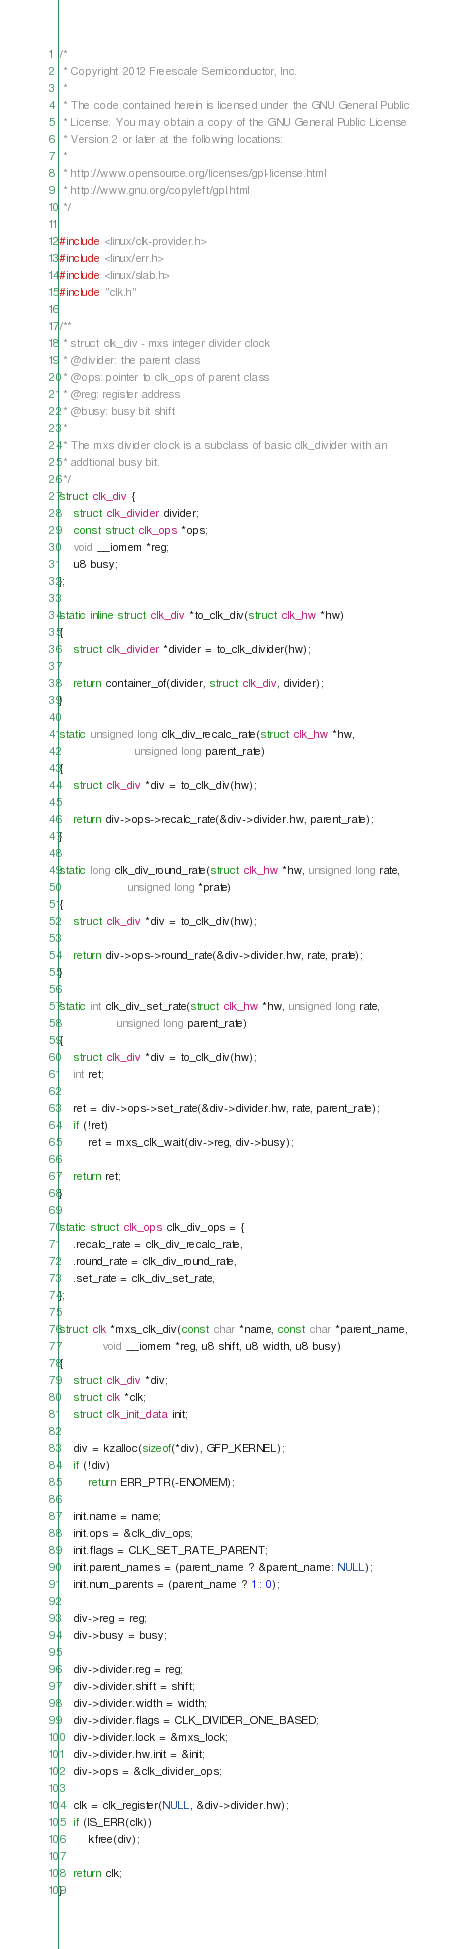<code> <loc_0><loc_0><loc_500><loc_500><_C_>/*
 * Copyright 2012 Freescale Semiconductor, Inc.
 *
 * The code contained herein is licensed under the GNU General Public
 * License. You may obtain a copy of the GNU General Public License
 * Version 2 or later at the following locations:
 *
 * http://www.opensource.org/licenses/gpl-license.html
 * http://www.gnu.org/copyleft/gpl.html
 */

#include <linux/clk-provider.h>
#include <linux/err.h>
#include <linux/slab.h>
#include "clk.h"

/**
 * struct clk_div - mxs integer divider clock
 * @divider: the parent class
 * @ops: pointer to clk_ops of parent class
 * @reg: register address
 * @busy: busy bit shift
 *
 * The mxs divider clock is a subclass of basic clk_divider with an
 * addtional busy bit.
 */
struct clk_div {
	struct clk_divider divider;
	const struct clk_ops *ops;
	void __iomem *reg;
	u8 busy;
};

static inline struct clk_div *to_clk_div(struct clk_hw *hw)
{
	struct clk_divider *divider = to_clk_divider(hw);

	return container_of(divider, struct clk_div, divider);
}

static unsigned long clk_div_recalc_rate(struct clk_hw *hw,
					 unsigned long parent_rate)
{
	struct clk_div *div = to_clk_div(hw);

	return div->ops->recalc_rate(&div->divider.hw, parent_rate);
}

static long clk_div_round_rate(struct clk_hw *hw, unsigned long rate,
			       unsigned long *prate)
{
	struct clk_div *div = to_clk_div(hw);

	return div->ops->round_rate(&div->divider.hw, rate, prate);
}

static int clk_div_set_rate(struct clk_hw *hw, unsigned long rate,
			    unsigned long parent_rate)
{
	struct clk_div *div = to_clk_div(hw);
	int ret;

	ret = div->ops->set_rate(&div->divider.hw, rate, parent_rate);
	if (!ret)
		ret = mxs_clk_wait(div->reg, div->busy);

	return ret;
}

static struct clk_ops clk_div_ops = {
	.recalc_rate = clk_div_recalc_rate,
	.round_rate = clk_div_round_rate,
	.set_rate = clk_div_set_rate,
};

struct clk *mxs_clk_div(const char *name, const char *parent_name,
			void __iomem *reg, u8 shift, u8 width, u8 busy)
{
	struct clk_div *div;
	struct clk *clk;
	struct clk_init_data init;

	div = kzalloc(sizeof(*div), GFP_KERNEL);
	if (!div)
		return ERR_PTR(-ENOMEM);

	init.name = name;
	init.ops = &clk_div_ops;
	init.flags = CLK_SET_RATE_PARENT;
	init.parent_names = (parent_name ? &parent_name: NULL);
	init.num_parents = (parent_name ? 1 : 0);

	div->reg = reg;
	div->busy = busy;

	div->divider.reg = reg;
	div->divider.shift = shift;
	div->divider.width = width;
	div->divider.flags = CLK_DIVIDER_ONE_BASED;
	div->divider.lock = &mxs_lock;
	div->divider.hw.init = &init;
	div->ops = &clk_divider_ops;

	clk = clk_register(NULL, &div->divider.hw);
	if (IS_ERR(clk))
		kfree(div);

	return clk;
}
</code> 